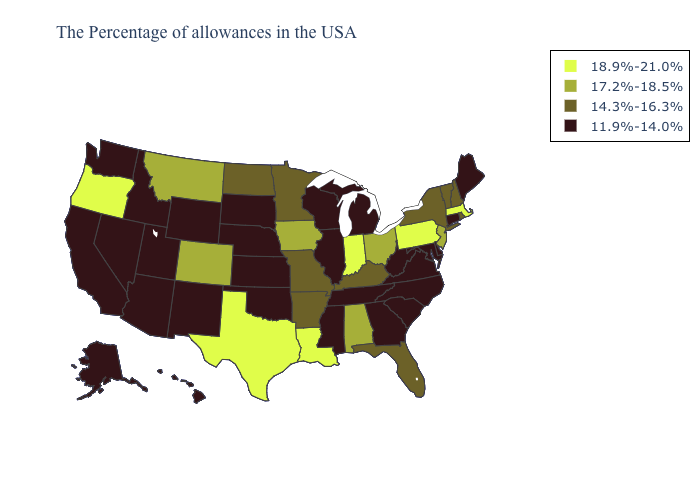What is the value of Idaho?
Answer briefly. 11.9%-14.0%. Which states have the lowest value in the USA?
Concise answer only. Maine, Connecticut, Delaware, Maryland, Virginia, North Carolina, South Carolina, West Virginia, Georgia, Michigan, Tennessee, Wisconsin, Illinois, Mississippi, Kansas, Nebraska, Oklahoma, South Dakota, Wyoming, New Mexico, Utah, Arizona, Idaho, Nevada, California, Washington, Alaska, Hawaii. Which states have the lowest value in the USA?
Write a very short answer. Maine, Connecticut, Delaware, Maryland, Virginia, North Carolina, South Carolina, West Virginia, Georgia, Michigan, Tennessee, Wisconsin, Illinois, Mississippi, Kansas, Nebraska, Oklahoma, South Dakota, Wyoming, New Mexico, Utah, Arizona, Idaho, Nevada, California, Washington, Alaska, Hawaii. Does Indiana have the highest value in the USA?
Answer briefly. Yes. Does Texas have the highest value in the USA?
Give a very brief answer. Yes. Name the states that have a value in the range 11.9%-14.0%?
Give a very brief answer. Maine, Connecticut, Delaware, Maryland, Virginia, North Carolina, South Carolina, West Virginia, Georgia, Michigan, Tennessee, Wisconsin, Illinois, Mississippi, Kansas, Nebraska, Oklahoma, South Dakota, Wyoming, New Mexico, Utah, Arizona, Idaho, Nevada, California, Washington, Alaska, Hawaii. Does Kansas have a higher value than California?
Keep it brief. No. Which states hav the highest value in the MidWest?
Give a very brief answer. Indiana. What is the lowest value in the USA?
Answer briefly. 11.9%-14.0%. Which states have the lowest value in the USA?
Short answer required. Maine, Connecticut, Delaware, Maryland, Virginia, North Carolina, South Carolina, West Virginia, Georgia, Michigan, Tennessee, Wisconsin, Illinois, Mississippi, Kansas, Nebraska, Oklahoma, South Dakota, Wyoming, New Mexico, Utah, Arizona, Idaho, Nevada, California, Washington, Alaska, Hawaii. Which states have the highest value in the USA?
Keep it brief. Massachusetts, Pennsylvania, Indiana, Louisiana, Texas, Oregon. Which states have the highest value in the USA?
Give a very brief answer. Massachusetts, Pennsylvania, Indiana, Louisiana, Texas, Oregon. Name the states that have a value in the range 17.2%-18.5%?
Short answer required. New Jersey, Ohio, Alabama, Iowa, Colorado, Montana. Among the states that border New York , does Vermont have the lowest value?
Concise answer only. No. What is the value of Virginia?
Write a very short answer. 11.9%-14.0%. 